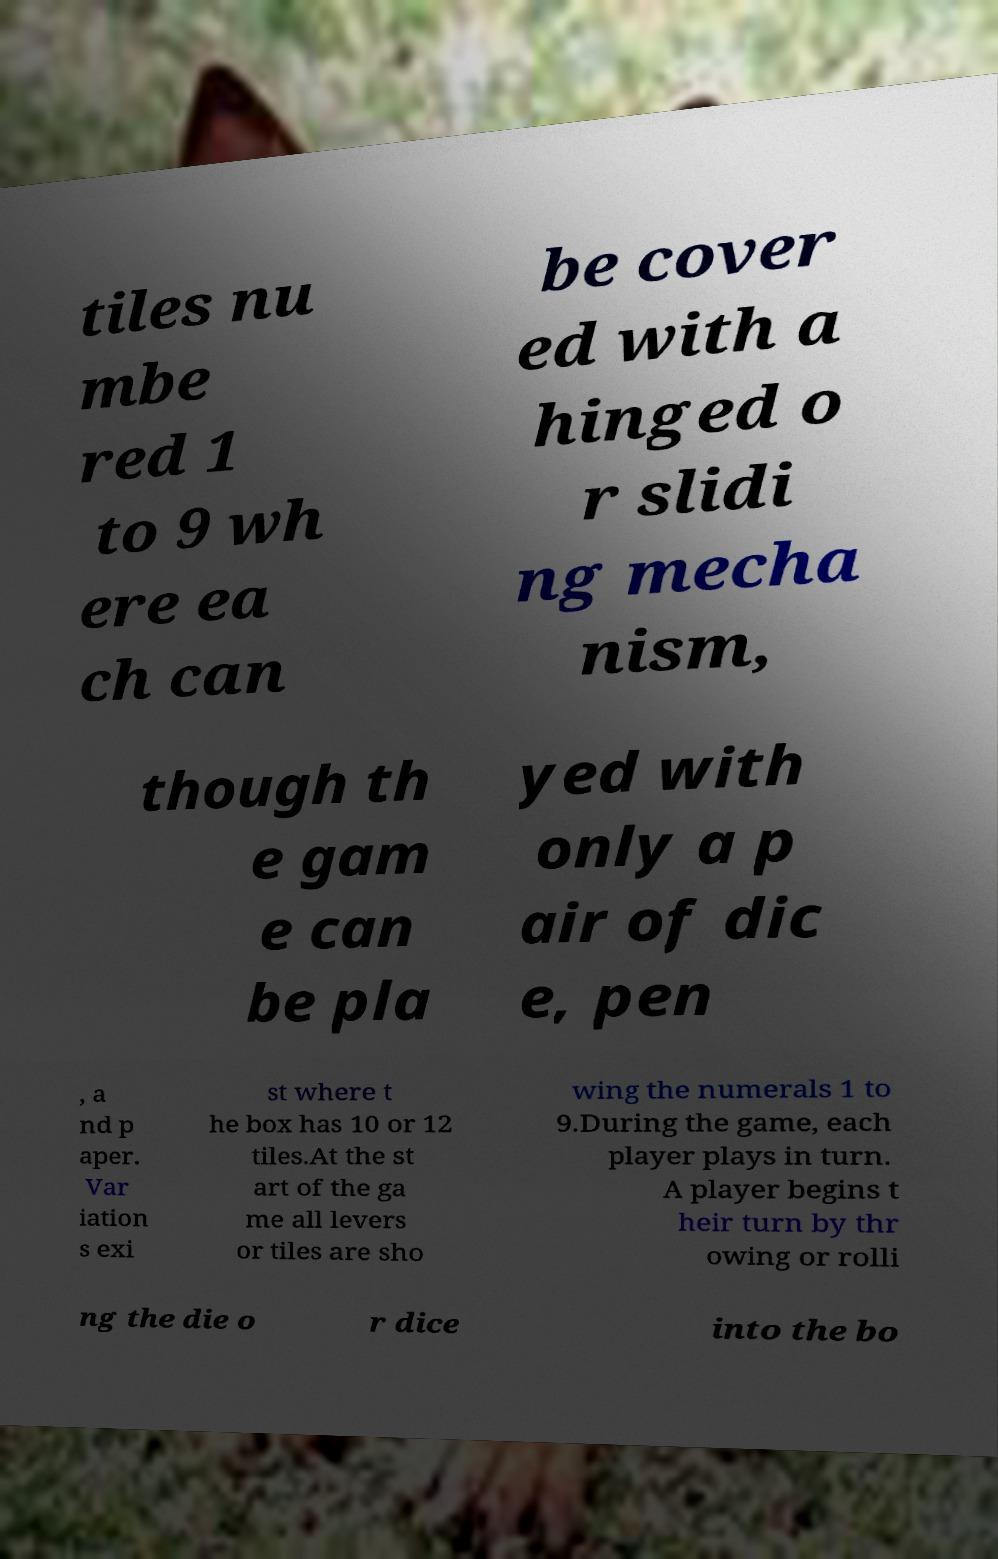Please read and relay the text visible in this image. What does it say? tiles nu mbe red 1 to 9 wh ere ea ch can be cover ed with a hinged o r slidi ng mecha nism, though th e gam e can be pla yed with only a p air of dic e, pen , a nd p aper. Var iation s exi st where t he box has 10 or 12 tiles.At the st art of the ga me all levers or tiles are sho wing the numerals 1 to 9.During the game, each player plays in turn. A player begins t heir turn by thr owing or rolli ng the die o r dice into the bo 